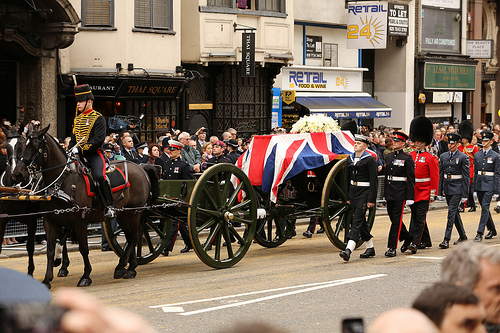What vehicle is it? The vehicle in the image is a wagon. 